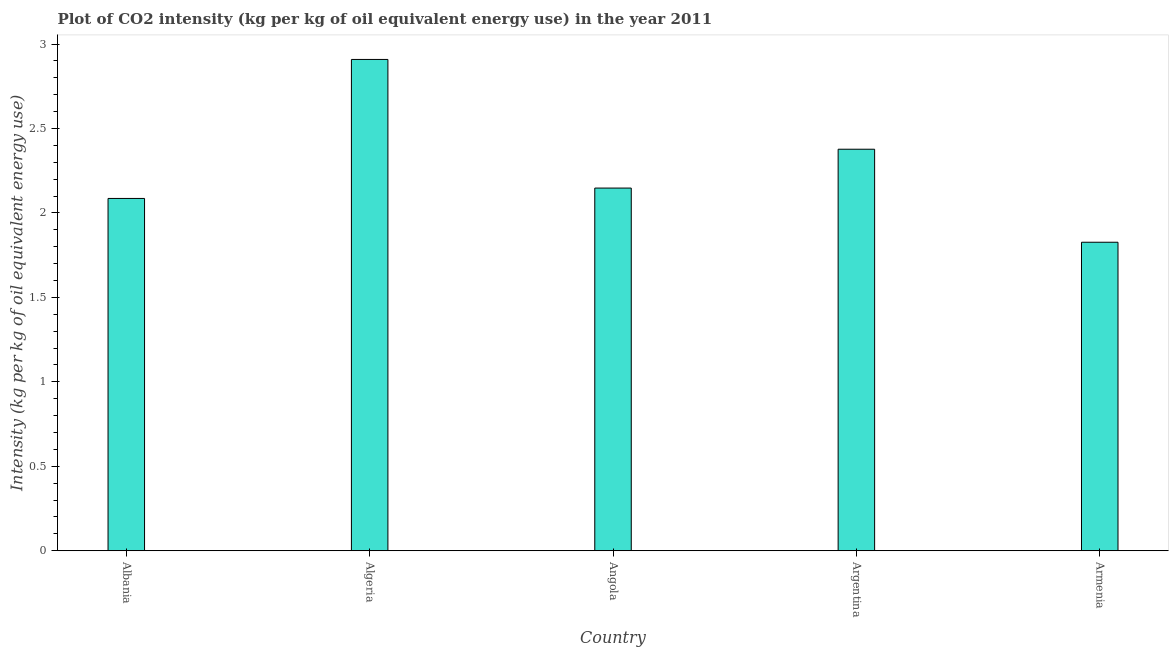What is the title of the graph?
Provide a succinct answer. Plot of CO2 intensity (kg per kg of oil equivalent energy use) in the year 2011. What is the label or title of the X-axis?
Offer a very short reply. Country. What is the label or title of the Y-axis?
Your response must be concise. Intensity (kg per kg of oil equivalent energy use). What is the co2 intensity in Argentina?
Your answer should be compact. 2.38. Across all countries, what is the maximum co2 intensity?
Your response must be concise. 2.91. Across all countries, what is the minimum co2 intensity?
Give a very brief answer. 1.83. In which country was the co2 intensity maximum?
Your answer should be compact. Algeria. In which country was the co2 intensity minimum?
Your response must be concise. Armenia. What is the sum of the co2 intensity?
Your response must be concise. 11.35. What is the difference between the co2 intensity in Argentina and Armenia?
Provide a short and direct response. 0.55. What is the average co2 intensity per country?
Keep it short and to the point. 2.27. What is the median co2 intensity?
Provide a succinct answer. 2.15. What is the ratio of the co2 intensity in Albania to that in Algeria?
Keep it short and to the point. 0.72. Is the co2 intensity in Albania less than that in Argentina?
Your answer should be compact. Yes. Is the difference between the co2 intensity in Albania and Armenia greater than the difference between any two countries?
Give a very brief answer. No. What is the difference between the highest and the second highest co2 intensity?
Give a very brief answer. 0.53. Is the sum of the co2 intensity in Albania and Armenia greater than the maximum co2 intensity across all countries?
Provide a short and direct response. Yes. How many bars are there?
Provide a short and direct response. 5. How many countries are there in the graph?
Offer a terse response. 5. What is the Intensity (kg per kg of oil equivalent energy use) of Albania?
Keep it short and to the point. 2.09. What is the Intensity (kg per kg of oil equivalent energy use) in Algeria?
Make the answer very short. 2.91. What is the Intensity (kg per kg of oil equivalent energy use) in Angola?
Provide a succinct answer. 2.15. What is the Intensity (kg per kg of oil equivalent energy use) in Argentina?
Provide a succinct answer. 2.38. What is the Intensity (kg per kg of oil equivalent energy use) in Armenia?
Keep it short and to the point. 1.83. What is the difference between the Intensity (kg per kg of oil equivalent energy use) in Albania and Algeria?
Make the answer very short. -0.82. What is the difference between the Intensity (kg per kg of oil equivalent energy use) in Albania and Angola?
Offer a terse response. -0.06. What is the difference between the Intensity (kg per kg of oil equivalent energy use) in Albania and Argentina?
Ensure brevity in your answer.  -0.29. What is the difference between the Intensity (kg per kg of oil equivalent energy use) in Albania and Armenia?
Offer a terse response. 0.26. What is the difference between the Intensity (kg per kg of oil equivalent energy use) in Algeria and Angola?
Your answer should be compact. 0.76. What is the difference between the Intensity (kg per kg of oil equivalent energy use) in Algeria and Argentina?
Make the answer very short. 0.53. What is the difference between the Intensity (kg per kg of oil equivalent energy use) in Algeria and Armenia?
Ensure brevity in your answer.  1.08. What is the difference between the Intensity (kg per kg of oil equivalent energy use) in Angola and Argentina?
Provide a short and direct response. -0.23. What is the difference between the Intensity (kg per kg of oil equivalent energy use) in Angola and Armenia?
Provide a succinct answer. 0.32. What is the difference between the Intensity (kg per kg of oil equivalent energy use) in Argentina and Armenia?
Make the answer very short. 0.55. What is the ratio of the Intensity (kg per kg of oil equivalent energy use) in Albania to that in Algeria?
Your response must be concise. 0.72. What is the ratio of the Intensity (kg per kg of oil equivalent energy use) in Albania to that in Argentina?
Your response must be concise. 0.88. What is the ratio of the Intensity (kg per kg of oil equivalent energy use) in Albania to that in Armenia?
Keep it short and to the point. 1.14. What is the ratio of the Intensity (kg per kg of oil equivalent energy use) in Algeria to that in Angola?
Provide a short and direct response. 1.35. What is the ratio of the Intensity (kg per kg of oil equivalent energy use) in Algeria to that in Argentina?
Make the answer very short. 1.22. What is the ratio of the Intensity (kg per kg of oil equivalent energy use) in Algeria to that in Armenia?
Provide a short and direct response. 1.59. What is the ratio of the Intensity (kg per kg of oil equivalent energy use) in Angola to that in Argentina?
Ensure brevity in your answer.  0.9. What is the ratio of the Intensity (kg per kg of oil equivalent energy use) in Angola to that in Armenia?
Provide a succinct answer. 1.18. What is the ratio of the Intensity (kg per kg of oil equivalent energy use) in Argentina to that in Armenia?
Provide a succinct answer. 1.3. 